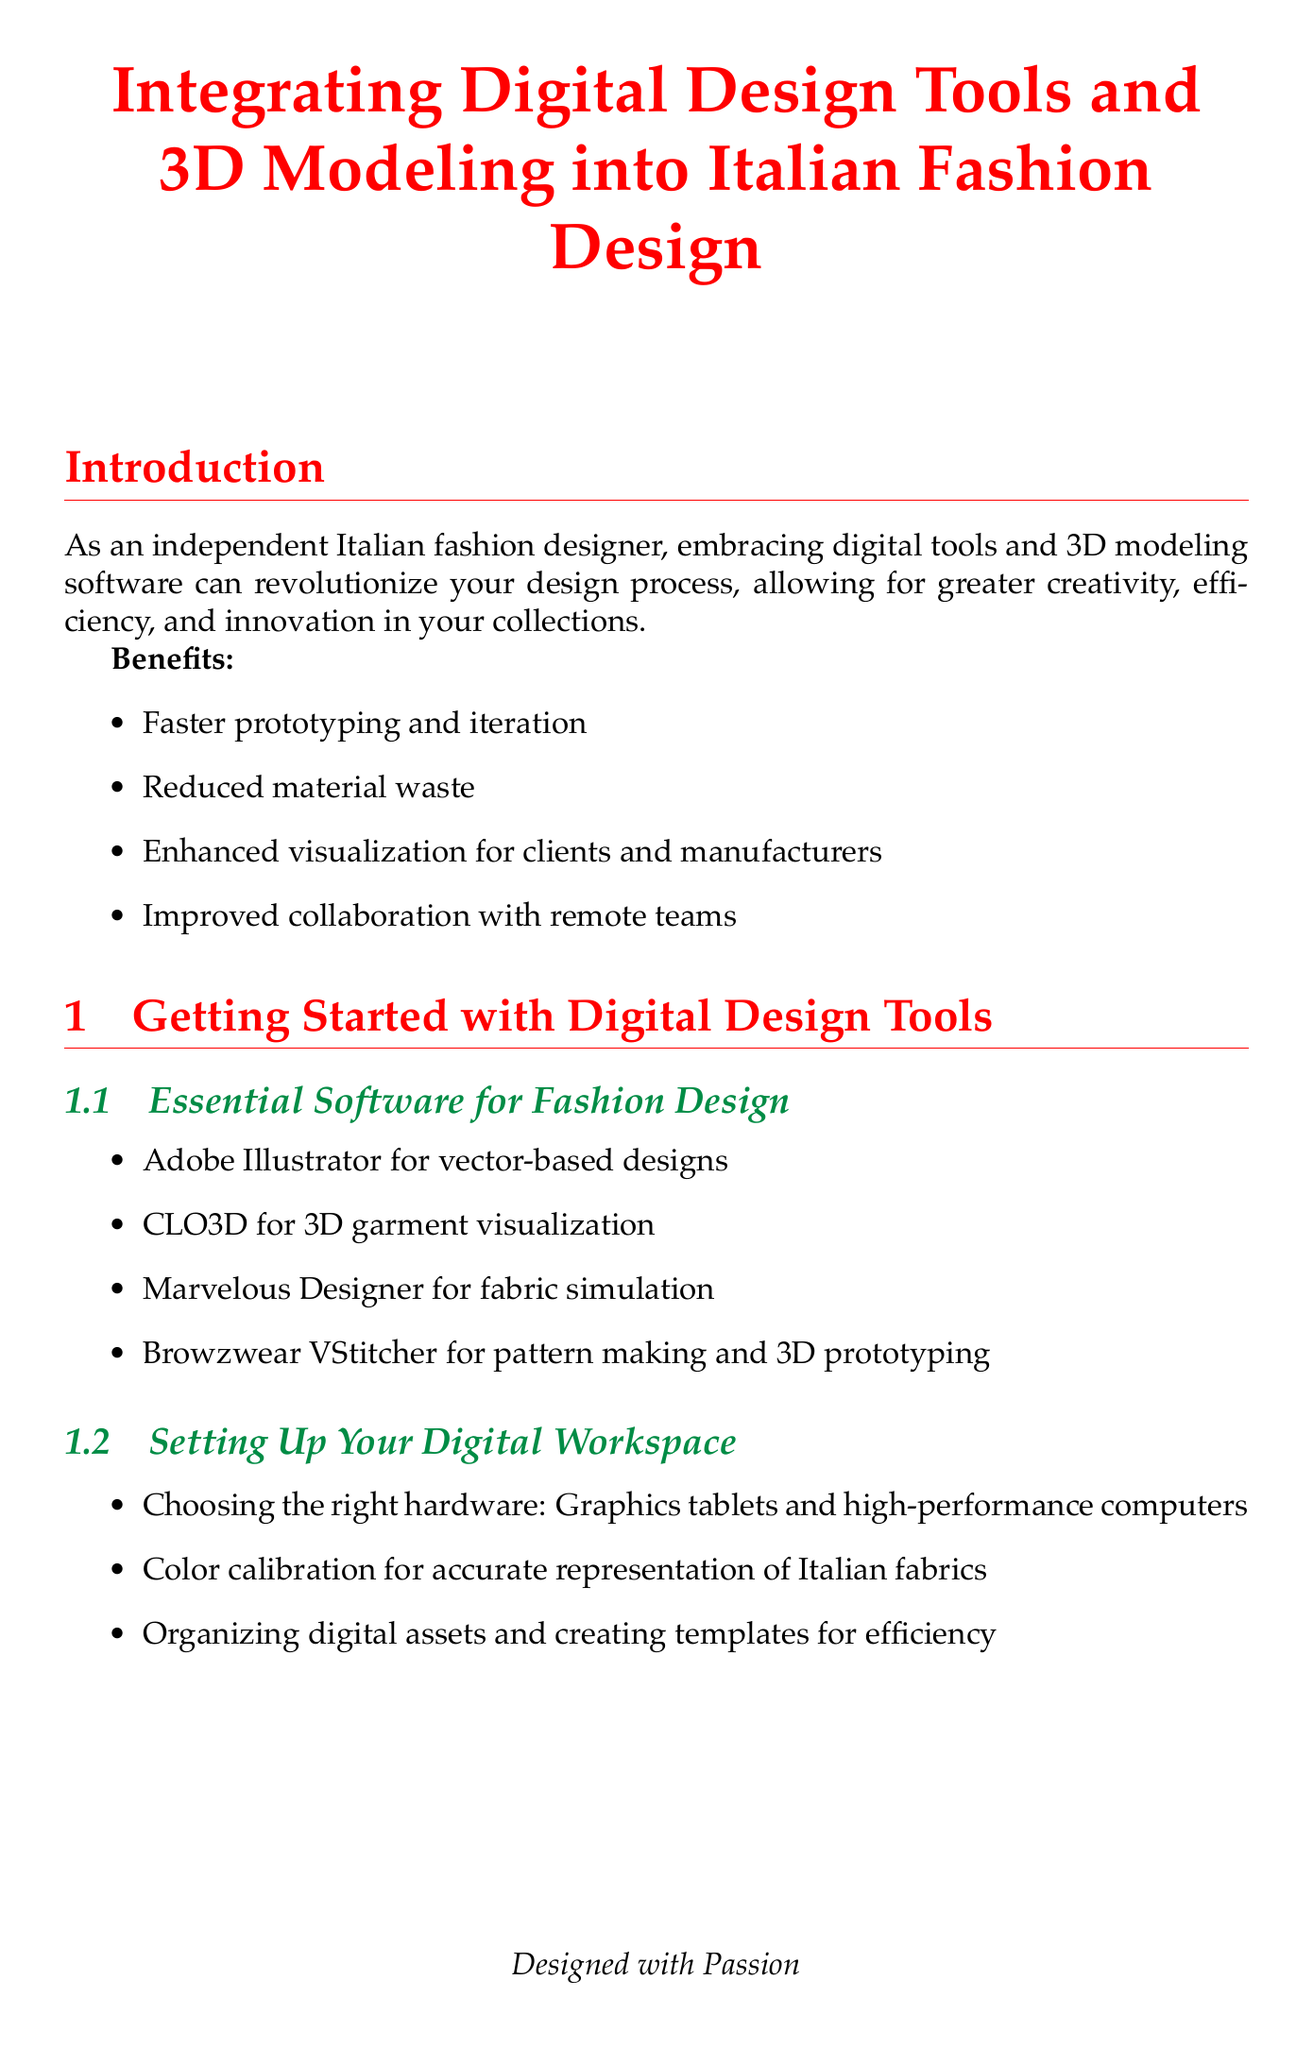What is the title of the manual? The title of the manual is specified at the beginning of the document.
Answer: Integrating Digital Design Tools and 3D Modeling into Italian Fashion Design What software is recommended for 3D garment visualization? The document lists essential software for fashion design, including specific applications for different tasks.
Answer: CLO3D What is one of the benefits of integrating digital tools into fashion design? The introduction outlines multiple benefits of using digital tools and 3D modeling software.
Answer: Reduced material waste Which section covers advanced techniques in Marvelous Designer? The chapters in the manual provide a structured approach to mastering different software tools and techniques.
Answer: Advanced Techniques in Marvelous Designer What is one method for creating digital avatars? Under virtual fittings, the document discusses ways to simulate fit on various body types using digital tools.
Answer: Creating digital avatars for various body types How many chapters does the manual contain? The structure of the manual provides a clear breakdown of its main sections, categorized by topic.
Answer: Five What is one way to present digital fashion designs? The section on presenting designs gives specific methods to showcase fashion collections digitally.
Answer: Creating stunning renders What do the next steps encourage designers to do? The conclusion section offers guidance on how to continue integrating digital tools into the design process.
Answer: Experiment with different software combinations to find your ideal workflow 